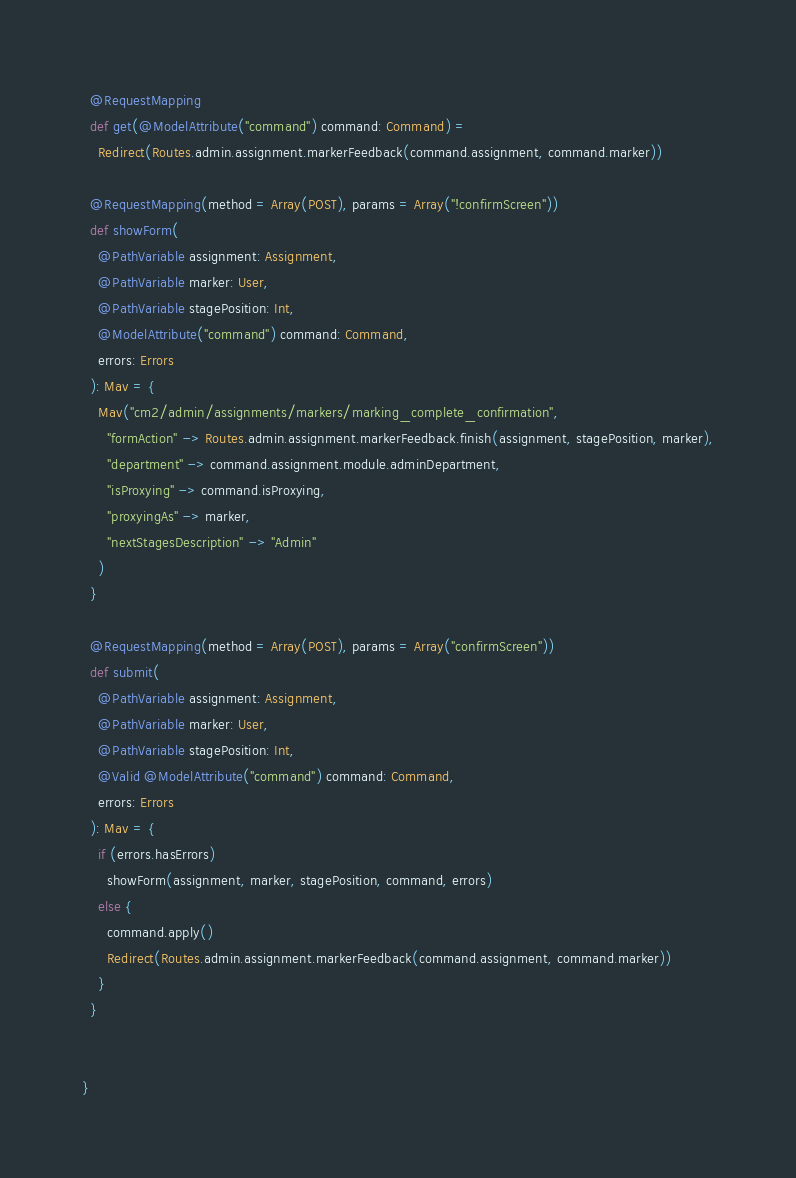<code> <loc_0><loc_0><loc_500><loc_500><_Scala_>  @RequestMapping
  def get(@ModelAttribute("command") command: Command) =
    Redirect(Routes.admin.assignment.markerFeedback(command.assignment, command.marker))

  @RequestMapping(method = Array(POST), params = Array("!confirmScreen"))
  def showForm(
    @PathVariable assignment: Assignment,
    @PathVariable marker: User,
    @PathVariable stagePosition: Int,
    @ModelAttribute("command") command: Command,
    errors: Errors
  ): Mav = {
    Mav("cm2/admin/assignments/markers/marking_complete_confirmation",
      "formAction" -> Routes.admin.assignment.markerFeedback.finish(assignment, stagePosition, marker),
      "department" -> command.assignment.module.adminDepartment,
      "isProxying" -> command.isProxying,
      "proxyingAs" -> marker,
      "nextStagesDescription" -> "Admin"
    )
  }

  @RequestMapping(method = Array(POST), params = Array("confirmScreen"))
  def submit(
    @PathVariable assignment: Assignment,
    @PathVariable marker: User,
    @PathVariable stagePosition: Int,
    @Valid @ModelAttribute("command") command: Command,
    errors: Errors
  ): Mav = {
    if (errors.hasErrors)
      showForm(assignment, marker, stagePosition, command, errors)
    else {
      command.apply()
      Redirect(Routes.admin.assignment.markerFeedback(command.assignment, command.marker))
    }
  }


}
</code> 